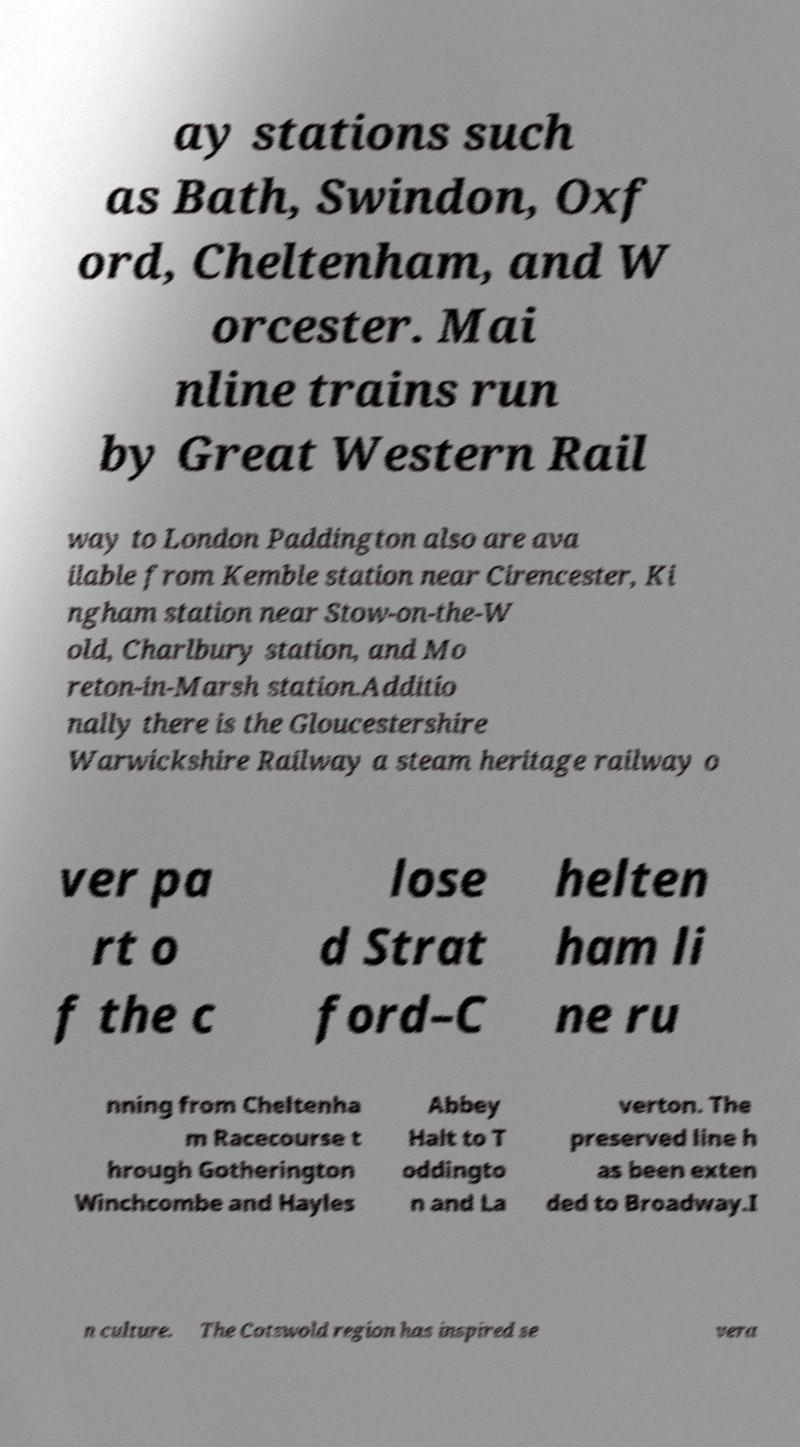Please identify and transcribe the text found in this image. ay stations such as Bath, Swindon, Oxf ord, Cheltenham, and W orcester. Mai nline trains run by Great Western Rail way to London Paddington also are ava ilable from Kemble station near Cirencester, Ki ngham station near Stow-on-the-W old, Charlbury station, and Mo reton-in-Marsh station.Additio nally there is the Gloucestershire Warwickshire Railway a steam heritage railway o ver pa rt o f the c lose d Strat ford–C helten ham li ne ru nning from Cheltenha m Racecourse t hrough Gotherington Winchcombe and Hayles Abbey Halt to T oddingto n and La verton. The preserved line h as been exten ded to Broadway.I n culture. The Cotswold region has inspired se vera 